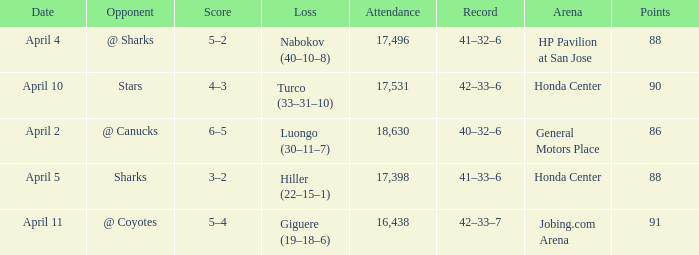Which Attendance has more than 90 points? 16438.0. 